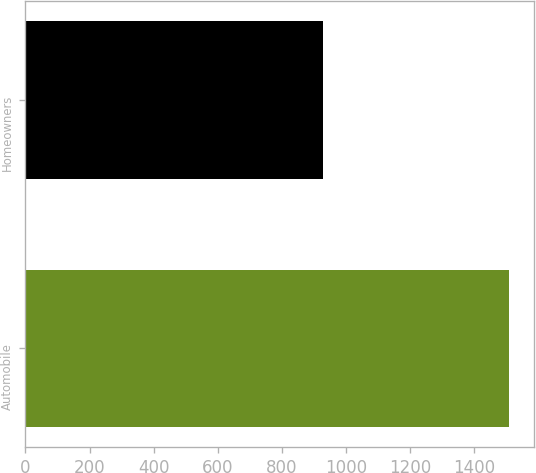Convert chart to OTSL. <chart><loc_0><loc_0><loc_500><loc_500><bar_chart><fcel>Automobile<fcel>Homeowners<nl><fcel>1510<fcel>927<nl></chart> 